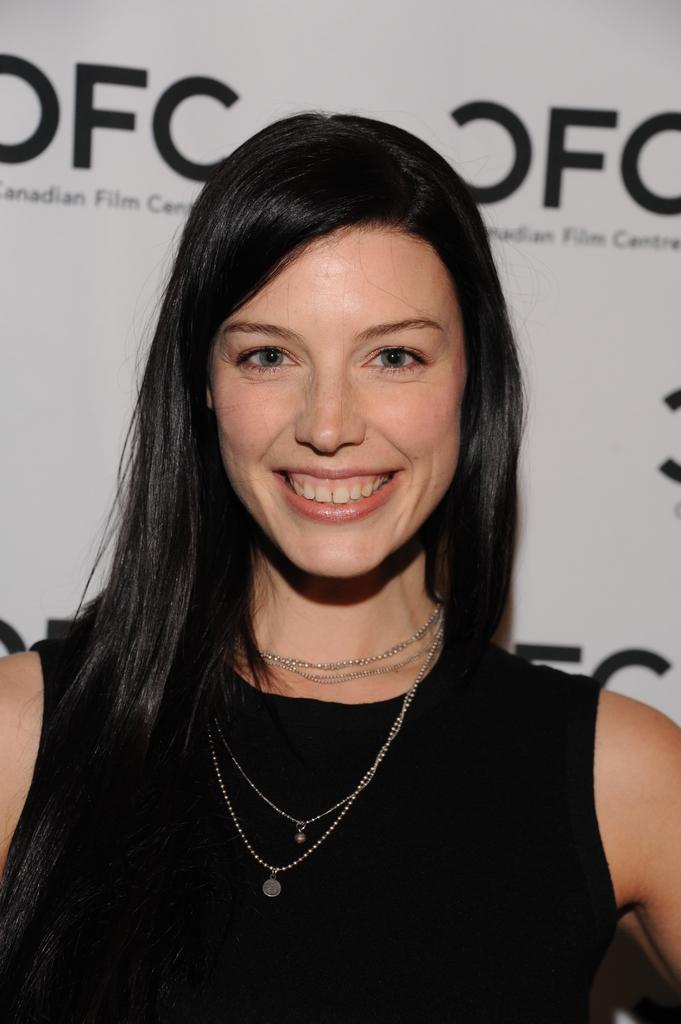Who is the main subject in the image? There is a woman in the center of the image. What expression does the woman have? The woman is smiling. What can be seen in the background of the image? There is a board in the background of the image. What is written on the board? There is text on the board. What type of milk is being poured from the chair in the image? There is no milk or chair present in the image. 